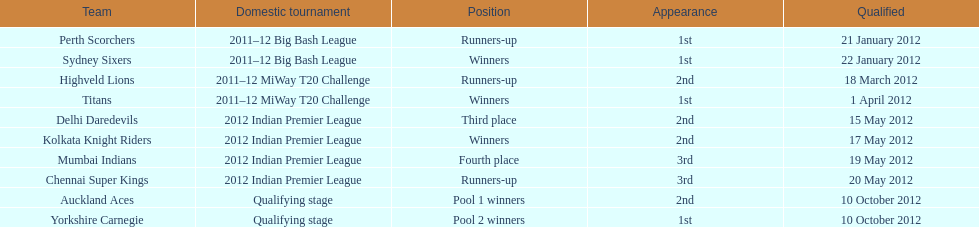Which team made their first appearance in the same tournament as the perth scorchers? Sydney Sixers. 